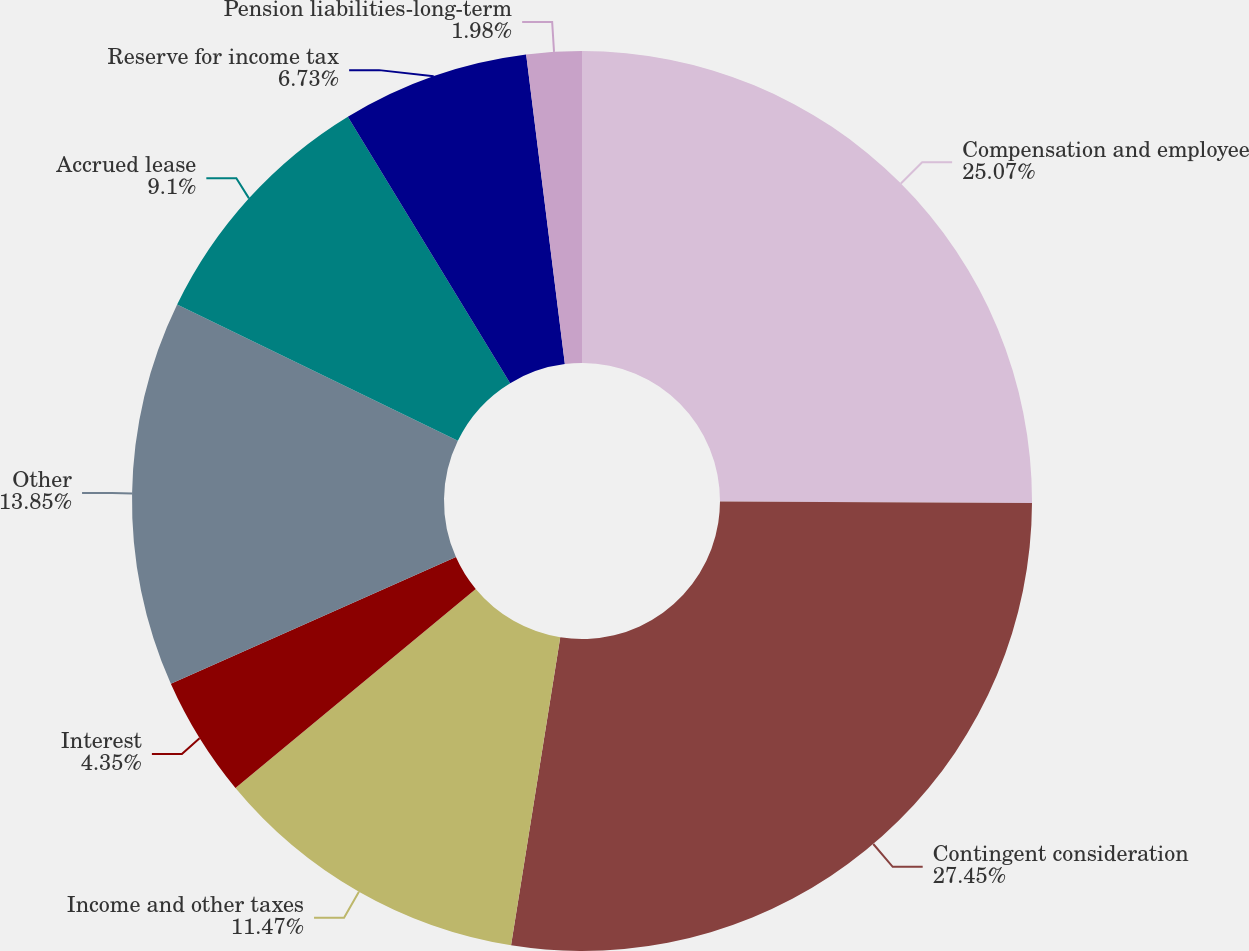<chart> <loc_0><loc_0><loc_500><loc_500><pie_chart><fcel>Compensation and employee<fcel>Contingent consideration<fcel>Income and other taxes<fcel>Interest<fcel>Other<fcel>Accrued lease<fcel>Reserve for income tax<fcel>Pension liabilities-long-term<nl><fcel>25.07%<fcel>27.45%<fcel>11.47%<fcel>4.35%<fcel>13.85%<fcel>9.1%<fcel>6.73%<fcel>1.98%<nl></chart> 